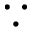Convert formula to latex. <formula><loc_0><loc_0><loc_500><loc_500>\because</formula> 